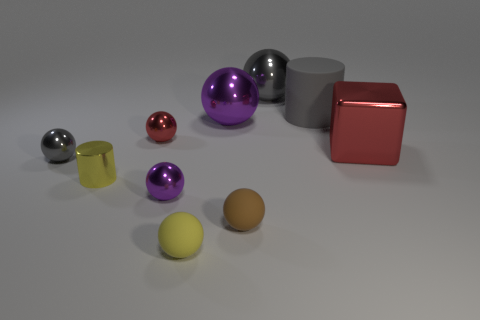The metal ball that is the same color as the block is what size?
Offer a very short reply. Small. Do the metal cube and the small metal thing behind the big red cube have the same color?
Offer a terse response. Yes. Is there anything else that is the same color as the metallic cube?
Keep it short and to the point. Yes. There is a small sphere that is the same color as the big rubber cylinder; what is it made of?
Provide a short and direct response. Metal. Does the red thing left of the brown ball have the same material as the large gray cylinder?
Offer a terse response. No. What shape is the rubber object that is the same color as the metal cylinder?
Give a very brief answer. Sphere. How many metallic objects are in front of the gray shiny sphere that is on the left side of the small red metal ball?
Your answer should be compact. 2. Are there fewer big red metal objects to the left of the small brown sphere than metal things that are left of the tiny red sphere?
Provide a short and direct response. Yes. There is a red metallic thing in front of the red metal ball that is in front of the large gray cylinder; what shape is it?
Offer a very short reply. Cube. How many other objects are the same material as the tiny red sphere?
Offer a very short reply. 6. 